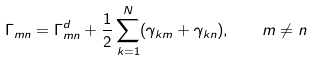Convert formula to latex. <formula><loc_0><loc_0><loc_500><loc_500>\Gamma _ { m n } = \Gamma _ { m n } ^ { d } + \frac { 1 } { 2 } \sum _ { k = 1 } ^ { N } ( \gamma _ { k m } + \gamma _ { k n } ) , \quad m \neq n</formula> 